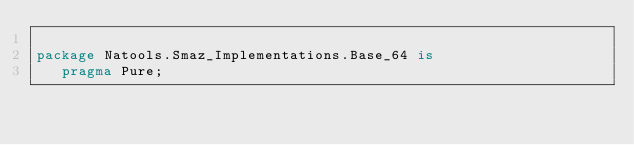Convert code to text. <code><loc_0><loc_0><loc_500><loc_500><_Ada_>
package Natools.Smaz_Implementations.Base_64 is
   pragma Pure;
</code> 